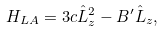<formula> <loc_0><loc_0><loc_500><loc_500>H _ { L A } = 3 c \hat { L } _ { z } ^ { 2 } - B ^ { \prime } \hat { L } _ { z } ,</formula> 